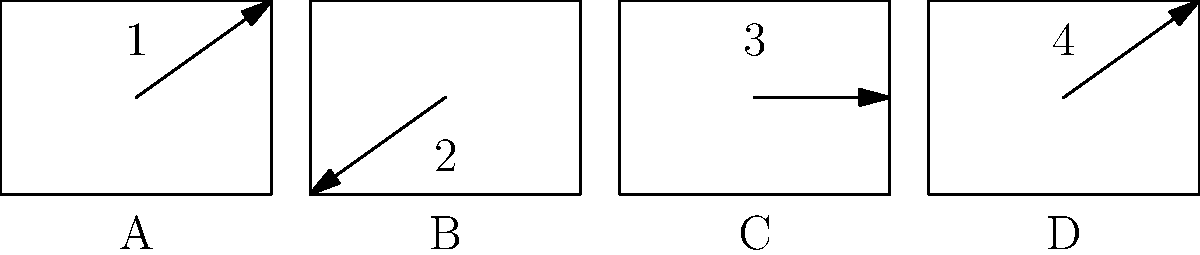In the storyboard sequence above, which frame represents a low-angle shot? To identify the low-angle shot in this storyboard sequence, we need to analyze each frame:

1. Frame A (1): The arrow points upwards, indicating a high-angle shot where the camera is positioned above the subject.

2. Frame B (2): The arrow points downwards, suggesting a low-angle shot where the camera is positioned below the subject, looking up.

3. Frame C (3): The arrow points straight ahead, representing a neutral or eye-level shot.

4. Frame D (4): The arrow points upwards, indicating another high-angle shot.

A low-angle shot is characterized by the camera being positioned below the subject, looking upwards. This creates a sense of power or dominance for the subject being filmed. In this storyboard sequence, only Frame B (2) shows this characteristic.
Answer: Frame B 